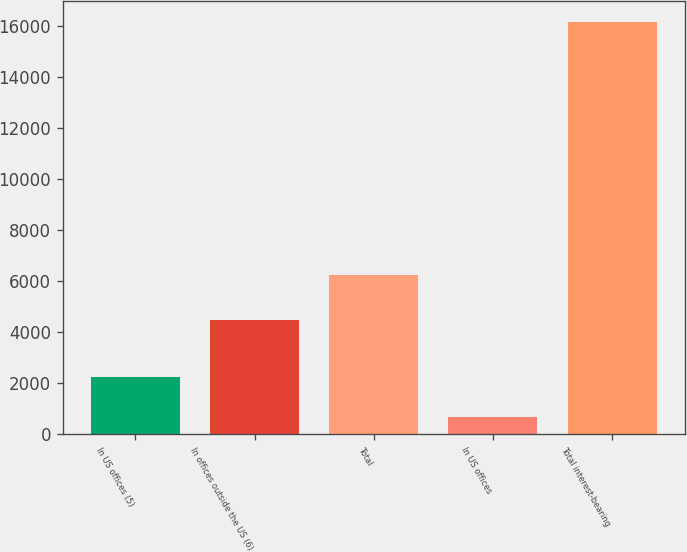Convert chart. <chart><loc_0><loc_0><loc_500><loc_500><bar_chart><fcel>In US offices (5)<fcel>In offices outside the US (6)<fcel>Total<fcel>In US offices<fcel>Total interest-bearing<nl><fcel>2227<fcel>4482<fcel>6236<fcel>677<fcel>16177<nl></chart> 